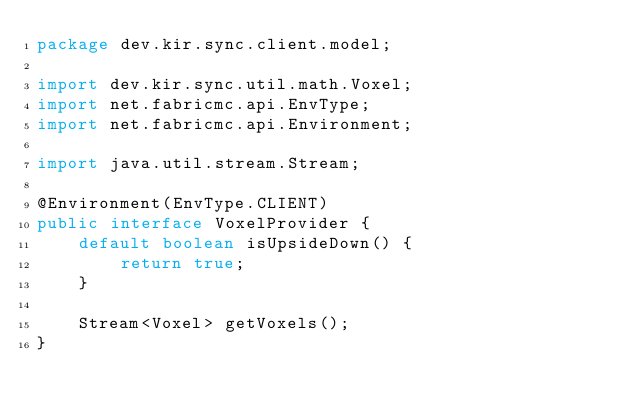<code> <loc_0><loc_0><loc_500><loc_500><_Java_>package dev.kir.sync.client.model;

import dev.kir.sync.util.math.Voxel;
import net.fabricmc.api.EnvType;
import net.fabricmc.api.Environment;

import java.util.stream.Stream;

@Environment(EnvType.CLIENT)
public interface VoxelProvider {
    default boolean isUpsideDown() {
        return true;
    }

    Stream<Voxel> getVoxels();
}</code> 